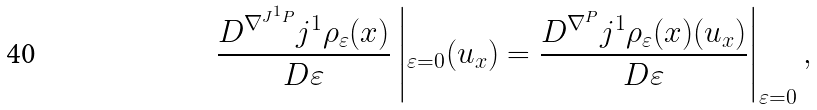Convert formula to latex. <formula><loc_0><loc_0><loc_500><loc_500>\frac { D ^ { \nabla ^ { J ^ { 1 } P } } j ^ { 1 } \rho _ { \varepsilon } ( x ) } { D \varepsilon } \left | _ { \varepsilon = 0 } ( u _ { x } ) = \frac { D ^ { \nabla ^ { P } } j ^ { 1 } \rho _ { \varepsilon } ( x ) ( u _ { x } ) } { D \varepsilon } \right | _ { \varepsilon = 0 } ,</formula> 